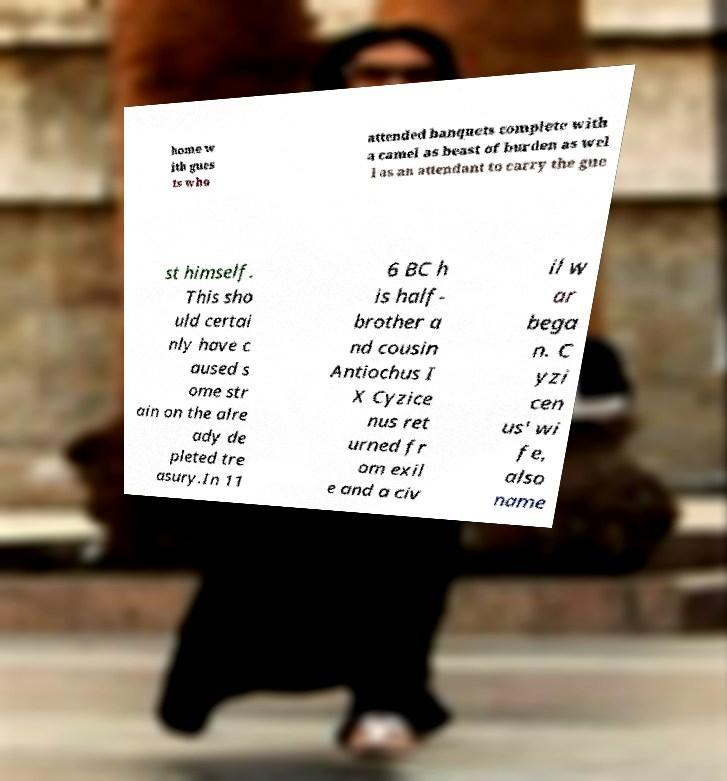Please read and relay the text visible in this image. What does it say? home w ith gues ts who attended banquets complete with a camel as beast of burden as wel l as an attendant to carry the gue st himself. This sho uld certai nly have c aused s ome str ain on the alre ady de pleted tre asury.In 11 6 BC h is half- brother a nd cousin Antiochus I X Cyzice nus ret urned fr om exil e and a civ il w ar bega n. C yzi cen us' wi fe, also name 